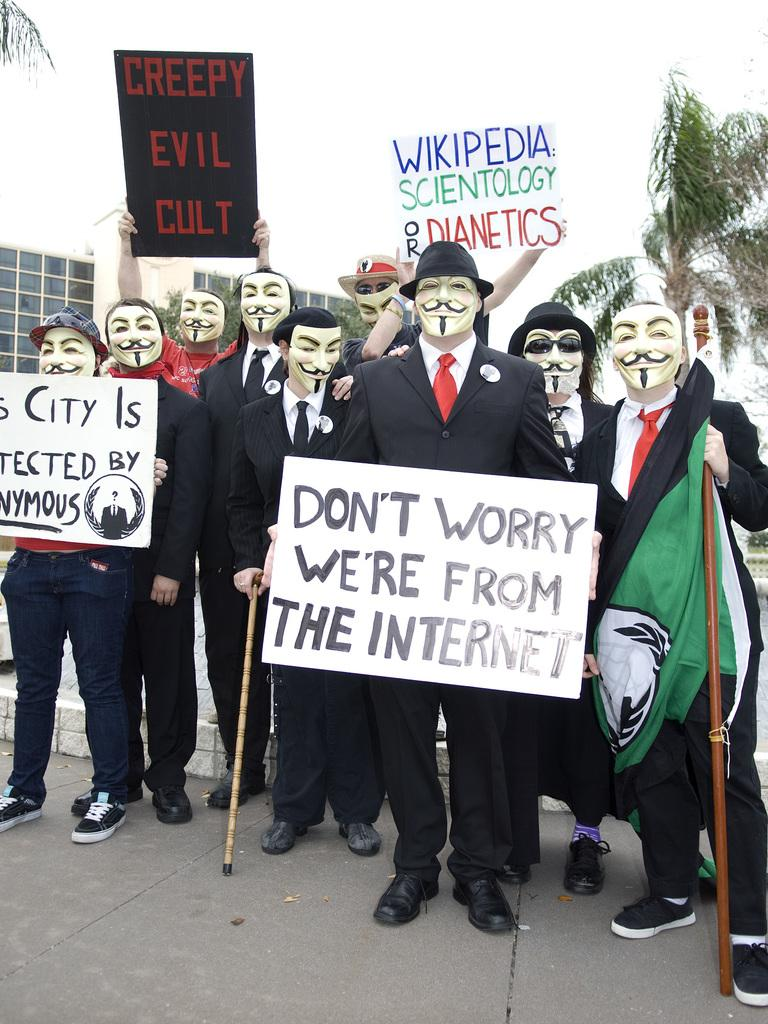<image>
Describe the image concisely. A group of people in masks are protesting something about the internet. 